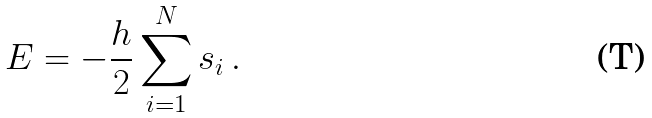Convert formula to latex. <formula><loc_0><loc_0><loc_500><loc_500>E = - \frac { h } { 2 } \sum _ { i = 1 } ^ { N } s _ { i } \, .</formula> 